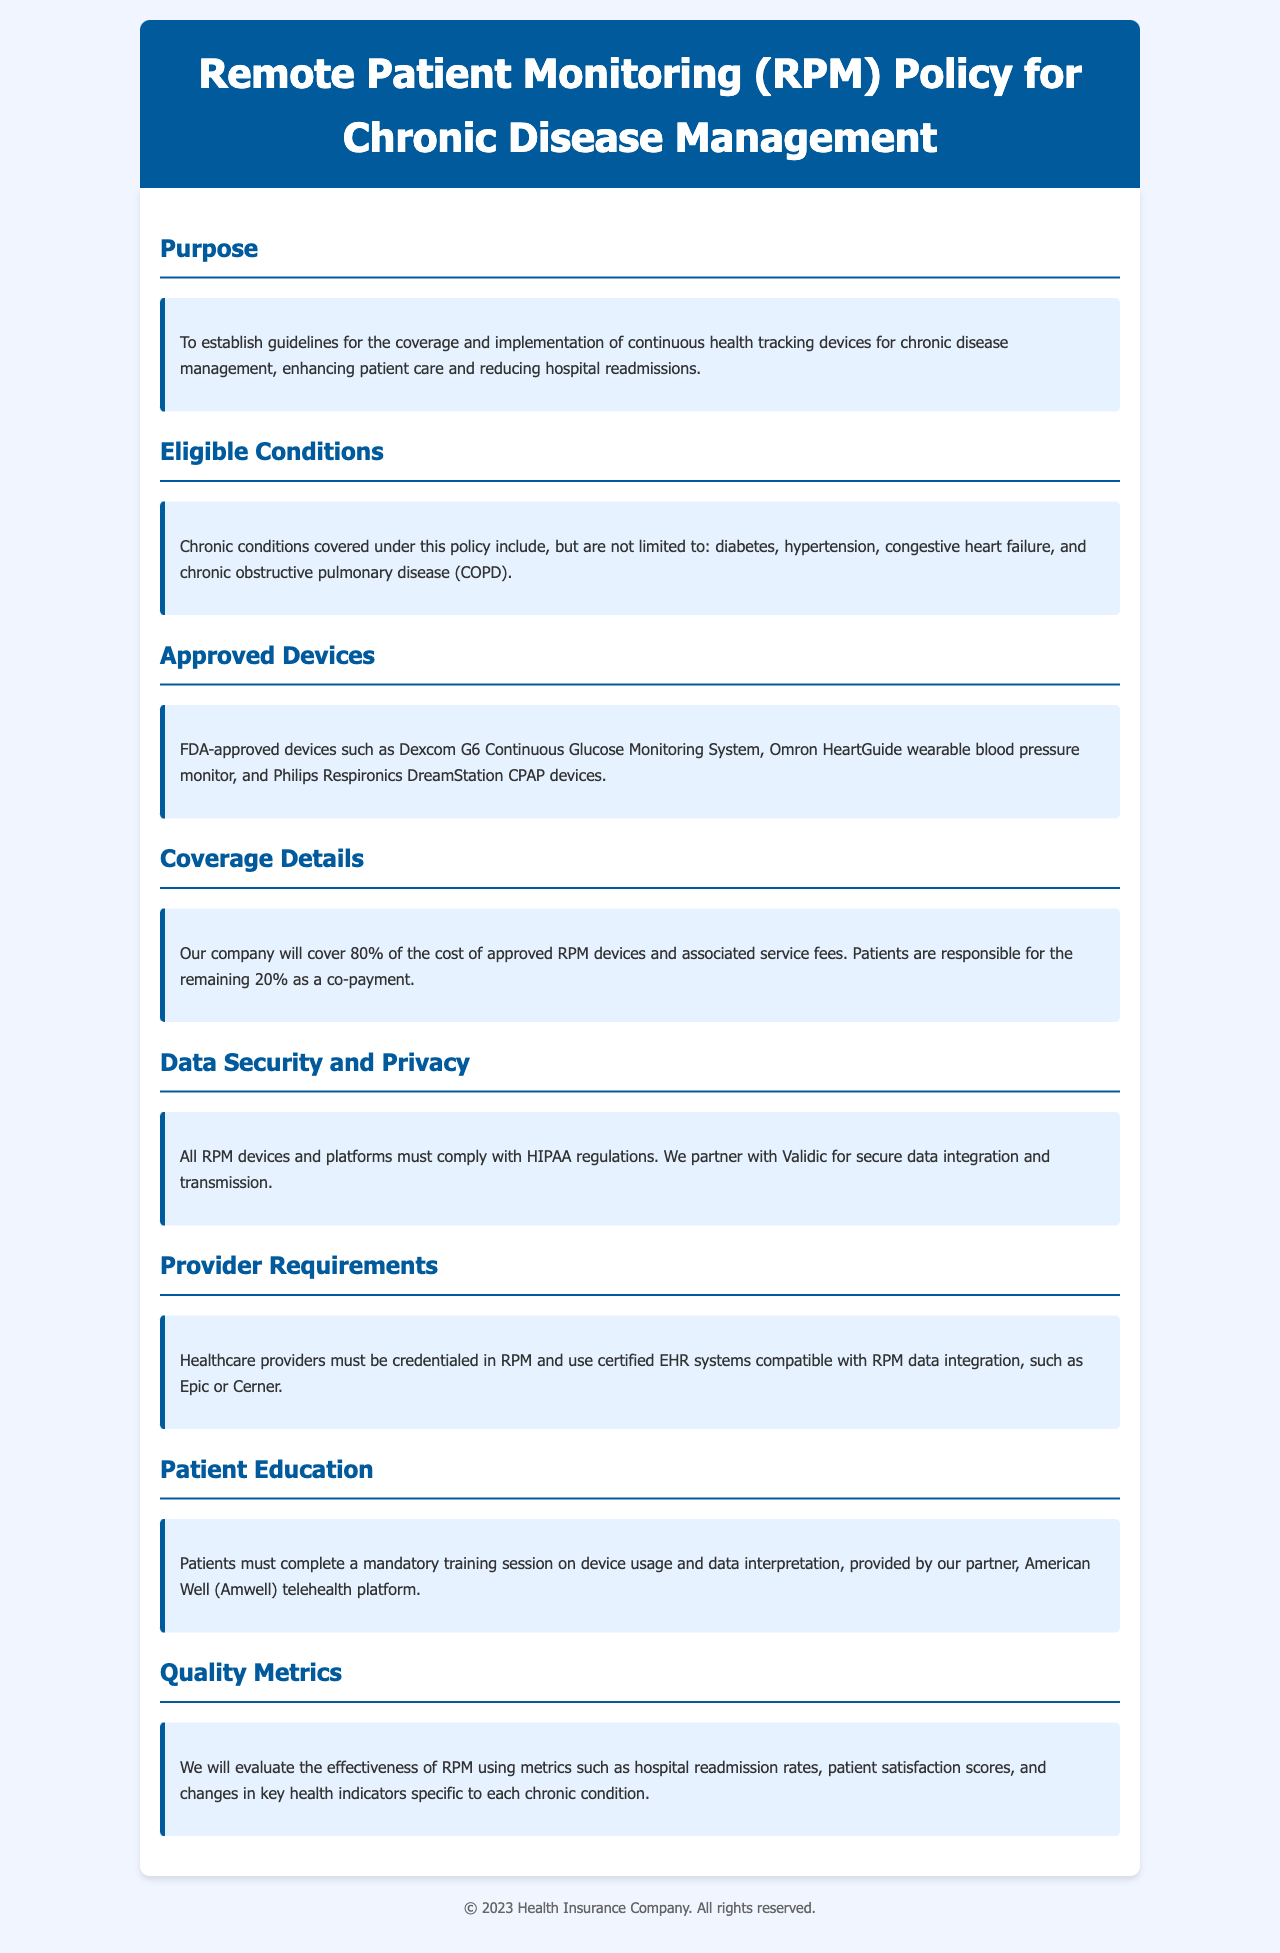What is the primary purpose of the RPM policy? The primary purpose is to establish guidelines for coverage and implementation of continuous health tracking devices for chronic disease management.
Answer: To establish guidelines for coverage and implementation of continuous health tracking devices for chronic disease management Which chronic conditions are eligible for RPM coverage? The eligible chronic conditions include diabetes, hypertension, congestive heart failure, and COPD.
Answer: diabetes, hypertension, congestive heart failure, and chronic obstructive pulmonary disease (COPD) What percentage of the cost is covered by the insurance company? The insurance company covers 80% of the cost of approved RPM devices and associated service fees.
Answer: 80% Who is the partner for secure data integration and transmission? The partner for secure data integration and transmission is Validic.
Answer: Validic What is the requirement for healthcare providers to use RPM? Healthcare providers must be credentialed in RPM and use certified EHR systems compatible with RPM data integration.
Answer: credentialed in RPM and use certified EHR systems Which platform provides the mandatory training session for patients? The mandatory training session for patients is provided by the American Well telehealth platform.
Answer: American Well (Amwell) What metrics will be used to evaluate RPM effectiveness? Metrics such as hospital readmission rates, patient satisfaction scores, and changes in key health indicators will be used.
Answer: hospital readmission rates, patient satisfaction scores, and changes in key health indicators What is the co-payment percentage that patients are responsible for? Patients are responsible for the remaining 20% as a co-payment.
Answer: 20% 